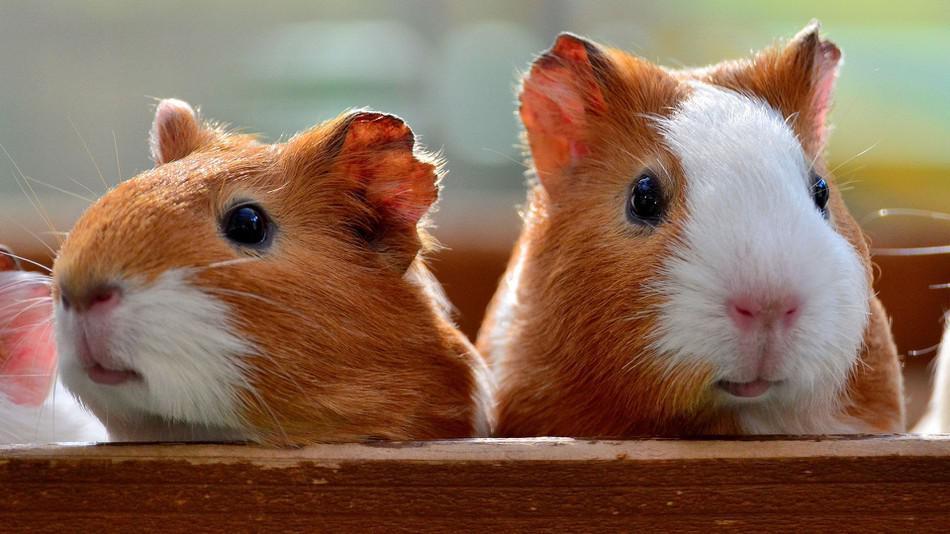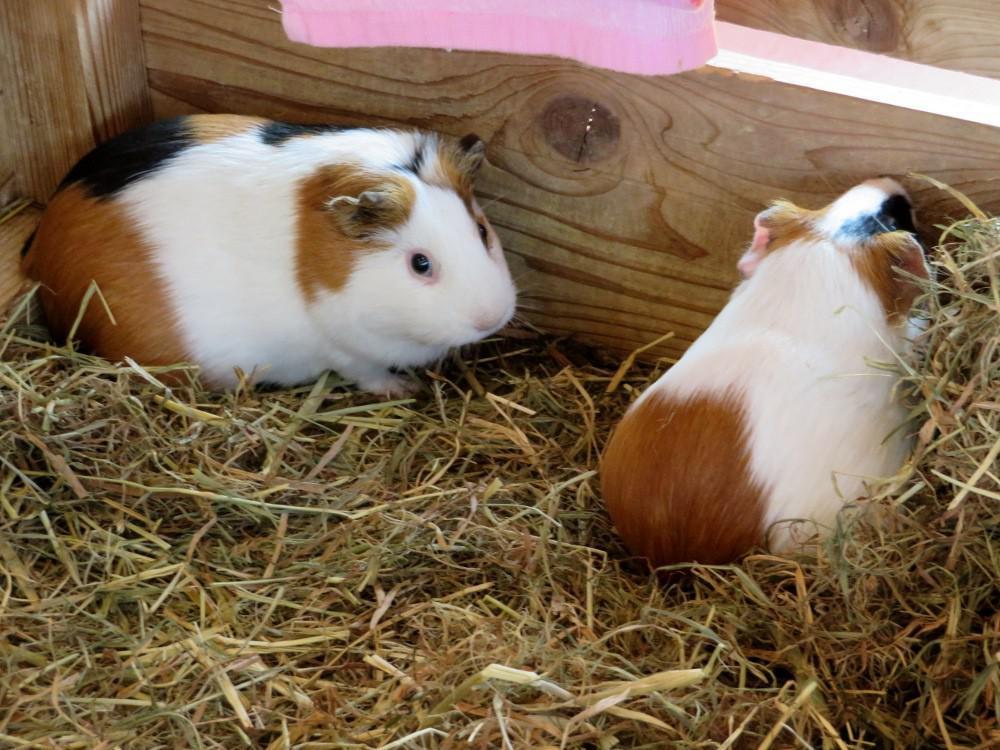The first image is the image on the left, the second image is the image on the right. For the images displayed, is the sentence "At least one of the pictures shows less than 10 rodents." factually correct? Answer yes or no. Yes. The first image is the image on the left, the second image is the image on the right. For the images displayed, is the sentence "Left image contains no more than five hamsters, which are in a wood-sided enclosure." factually correct? Answer yes or no. Yes. 